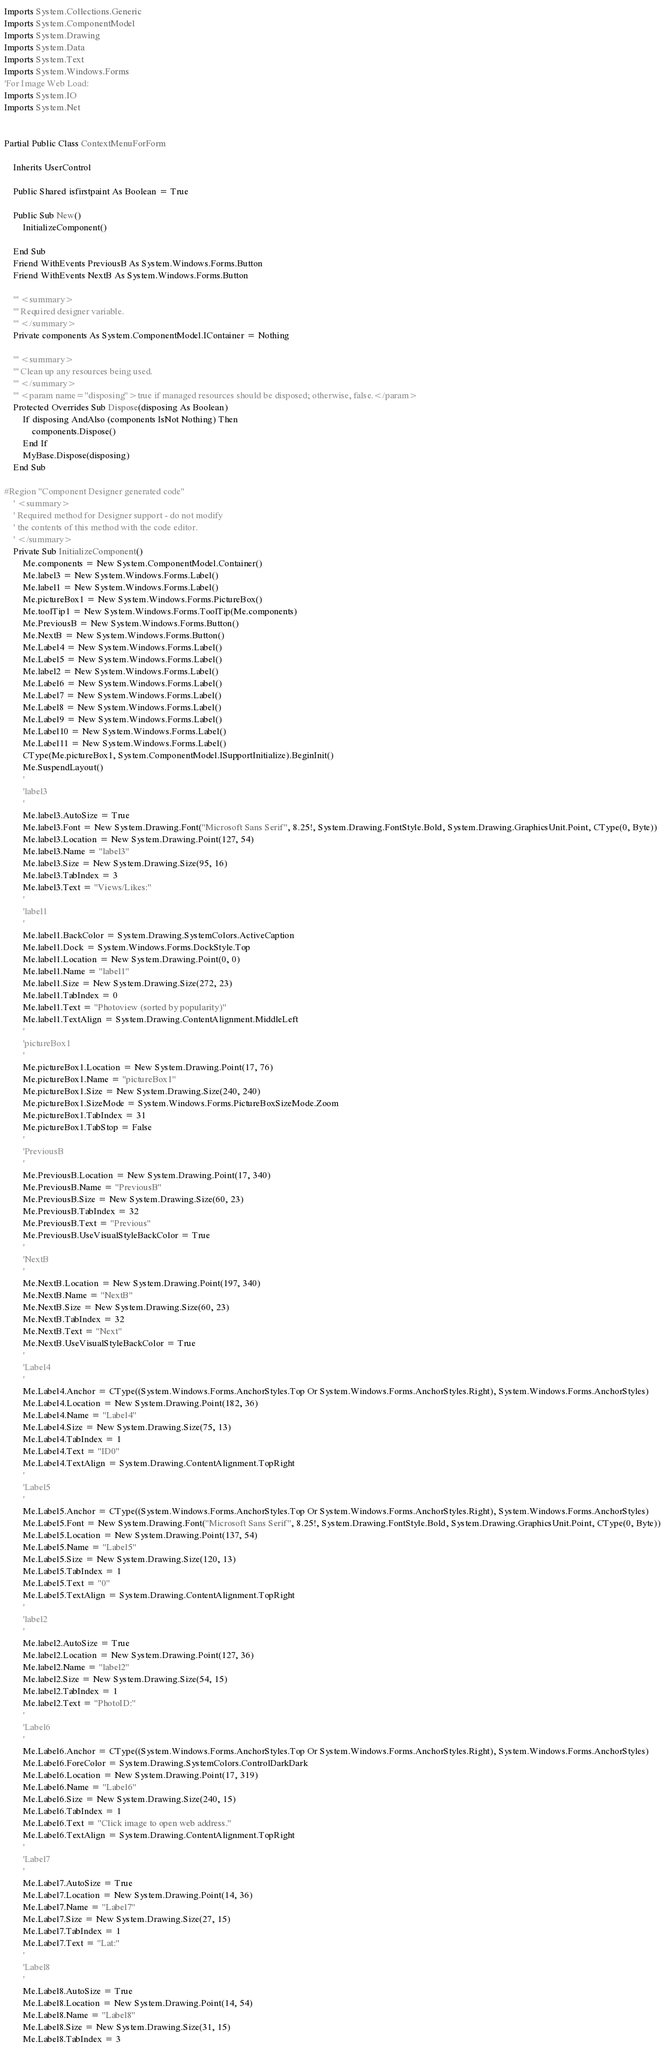Convert code to text. <code><loc_0><loc_0><loc_500><loc_500><_VisualBasic_>Imports System.Collections.Generic
Imports System.ComponentModel
Imports System.Drawing
Imports System.Data
Imports System.Text
Imports System.Windows.Forms
'For Image Web Load:
Imports System.IO
Imports System.Net


Partial Public Class ContextMenuForForm

    Inherits UserControl

    Public Shared isfirstpaint As Boolean = True

    Public Sub New()
        InitializeComponent()

    End Sub
    Friend WithEvents PreviousB As System.Windows.Forms.Button
    Friend WithEvents NextB As System.Windows.Forms.Button

    ''' <summary> 
    ''' Required designer variable.
    ''' </summary>
    Private components As System.ComponentModel.IContainer = Nothing

    ''' <summary> 
    ''' Clean up any resources being used.
    ''' </summary>
    ''' <param name="disposing">true if managed resources should be disposed; otherwise, false.</param>
    Protected Overrides Sub Dispose(disposing As Boolean)
        If disposing AndAlso (components IsNot Nothing) Then
            components.Dispose()
        End If
        MyBase.Dispose(disposing)
    End Sub

#Region "Component Designer generated code"
    ' <summary> 
    ' Required method for Designer support - do not modify 
    ' the contents of this method with the code editor.
    ' </summary>
    Private Sub InitializeComponent()
        Me.components = New System.ComponentModel.Container()
        Me.label3 = New System.Windows.Forms.Label()
        Me.label1 = New System.Windows.Forms.Label()
        Me.pictureBox1 = New System.Windows.Forms.PictureBox()
        Me.toolTip1 = New System.Windows.Forms.ToolTip(Me.components)
        Me.PreviousB = New System.Windows.Forms.Button()
        Me.NextB = New System.Windows.Forms.Button()
        Me.Label4 = New System.Windows.Forms.Label()
        Me.Label5 = New System.Windows.Forms.Label()
        Me.label2 = New System.Windows.Forms.Label()
        Me.Label6 = New System.Windows.Forms.Label()
        Me.Label7 = New System.Windows.Forms.Label()
        Me.Label8 = New System.Windows.Forms.Label()
        Me.Label9 = New System.Windows.Forms.Label()
        Me.Label10 = New System.Windows.Forms.Label()
        Me.Label11 = New System.Windows.Forms.Label()
        CType(Me.pictureBox1, System.ComponentModel.ISupportInitialize).BeginInit()
        Me.SuspendLayout()
        '
        'label3
        '
        Me.label3.AutoSize = True
        Me.label3.Font = New System.Drawing.Font("Microsoft Sans Serif", 8.25!, System.Drawing.FontStyle.Bold, System.Drawing.GraphicsUnit.Point, CType(0, Byte))
        Me.label3.Location = New System.Drawing.Point(127, 54)
        Me.label3.Name = "label3"
        Me.label3.Size = New System.Drawing.Size(95, 16)
        Me.label3.TabIndex = 3
        Me.label3.Text = "Views/Likes:"
        '
        'label1
        '
        Me.label1.BackColor = System.Drawing.SystemColors.ActiveCaption
        Me.label1.Dock = System.Windows.Forms.DockStyle.Top
        Me.label1.Location = New System.Drawing.Point(0, 0)
        Me.label1.Name = "label1"
        Me.label1.Size = New System.Drawing.Size(272, 23)
        Me.label1.TabIndex = 0
        Me.label1.Text = "Photoview (sorted by popularity)"
        Me.label1.TextAlign = System.Drawing.ContentAlignment.MiddleLeft
        '
        'pictureBox1
        '
        Me.pictureBox1.Location = New System.Drawing.Point(17, 76)
        Me.pictureBox1.Name = "pictureBox1"
        Me.pictureBox1.Size = New System.Drawing.Size(240, 240)
        Me.pictureBox1.SizeMode = System.Windows.Forms.PictureBoxSizeMode.Zoom
        Me.pictureBox1.TabIndex = 31
        Me.pictureBox1.TabStop = False
        '
        'PreviousB
        '
        Me.PreviousB.Location = New System.Drawing.Point(17, 340)
        Me.PreviousB.Name = "PreviousB"
        Me.PreviousB.Size = New System.Drawing.Size(60, 23)
        Me.PreviousB.TabIndex = 32
        Me.PreviousB.Text = "Previous"
        Me.PreviousB.UseVisualStyleBackColor = True
        '
        'NextB
        '
        Me.NextB.Location = New System.Drawing.Point(197, 340)
        Me.NextB.Name = "NextB"
        Me.NextB.Size = New System.Drawing.Size(60, 23)
        Me.NextB.TabIndex = 32
        Me.NextB.Text = "Next"
        Me.NextB.UseVisualStyleBackColor = True
        '
        'Label4
        '
        Me.Label4.Anchor = CType((System.Windows.Forms.AnchorStyles.Top Or System.Windows.Forms.AnchorStyles.Right), System.Windows.Forms.AnchorStyles)
        Me.Label4.Location = New System.Drawing.Point(182, 36)
        Me.Label4.Name = "Label4"
        Me.Label4.Size = New System.Drawing.Size(75, 13)
        Me.Label4.TabIndex = 1
        Me.Label4.Text = "ID0"
        Me.Label4.TextAlign = System.Drawing.ContentAlignment.TopRight
        '
        'Label5
        '
        Me.Label5.Anchor = CType((System.Windows.Forms.AnchorStyles.Top Or System.Windows.Forms.AnchorStyles.Right), System.Windows.Forms.AnchorStyles)
        Me.Label5.Font = New System.Drawing.Font("Microsoft Sans Serif", 8.25!, System.Drawing.FontStyle.Bold, System.Drawing.GraphicsUnit.Point, CType(0, Byte))
        Me.Label5.Location = New System.Drawing.Point(137, 54)
        Me.Label5.Name = "Label5"
        Me.Label5.Size = New System.Drawing.Size(120, 13)
        Me.Label5.TabIndex = 1
        Me.Label5.Text = "0"
        Me.Label5.TextAlign = System.Drawing.ContentAlignment.TopRight
        '
        'label2
        '
        Me.label2.AutoSize = True
        Me.label2.Location = New System.Drawing.Point(127, 36)
        Me.label2.Name = "label2"
        Me.label2.Size = New System.Drawing.Size(54, 15)
        Me.label2.TabIndex = 1
        Me.label2.Text = "PhotoID:"
        '
        'Label6
        '
        Me.Label6.Anchor = CType((System.Windows.Forms.AnchorStyles.Top Or System.Windows.Forms.AnchorStyles.Right), System.Windows.Forms.AnchorStyles)
        Me.Label6.ForeColor = System.Drawing.SystemColors.ControlDarkDark
        Me.Label6.Location = New System.Drawing.Point(17, 319)
        Me.Label6.Name = "Label6"
        Me.Label6.Size = New System.Drawing.Size(240, 15)
        Me.Label6.TabIndex = 1
        Me.Label6.Text = "Click image to open web address."
        Me.Label6.TextAlign = System.Drawing.ContentAlignment.TopRight
        '
        'Label7
        '
        Me.Label7.AutoSize = True
        Me.Label7.Location = New System.Drawing.Point(14, 36)
        Me.Label7.Name = "Label7"
        Me.Label7.Size = New System.Drawing.Size(27, 15)
        Me.Label7.TabIndex = 1
        Me.Label7.Text = "Lat:"
        '
        'Label8
        '
        Me.Label8.AutoSize = True
        Me.Label8.Location = New System.Drawing.Point(14, 54)
        Me.Label8.Name = "Label8"
        Me.Label8.Size = New System.Drawing.Size(31, 15)
        Me.Label8.TabIndex = 3</code> 